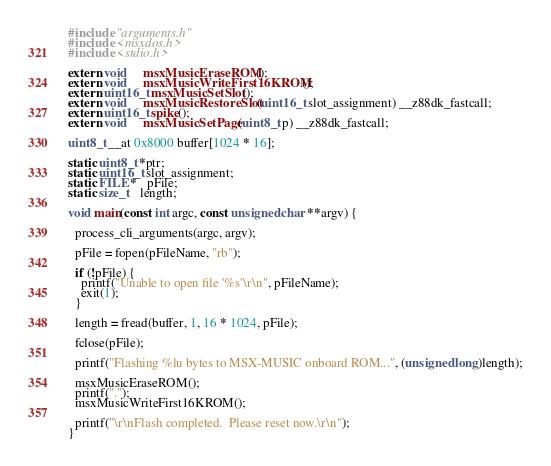Convert code to text. <code><loc_0><loc_0><loc_500><loc_500><_C_>#include "arguments.h"
#include <msxdos.h>
#include <stdio.h>

extern void     msxMusicEraseROM();
extern void     msxMusicWriteFirst16KROM();
extern uint16_t msxMusicSetSlot();
extern void     msxMusicRestoreSlot(uint16_t slot_assignment) __z88dk_fastcall;
extern uint16_t spike();
extern void     msxMusicSetPage(uint8_t p) __z88dk_fastcall;

uint8_t __at 0x8000 buffer[1024 * 16];

static uint8_t *ptr;
static uint16_t slot_assignment;
static FILE *   pFile;
static size_t   length;

void main(const int argc, const unsigned char **argv) {

  process_cli_arguments(argc, argv);

  pFile = fopen(pFileName, "rb");

  if (!pFile) {
    printf("Unable to open file '%s'\r\n", pFileName);
    exit(1);
  }

  length = fread(buffer, 1, 16 * 1024, pFile);

  fclose(pFile);

  printf("Flashing %lu bytes to MSX-MUSIC onboard ROM...", (unsigned long)length);

  msxMusicEraseROM();
  printf(".");
  msxMusicWriteFirst16KROM();

  printf("\r\nFlash completed.  Please reset now.\r\n");
}
</code> 